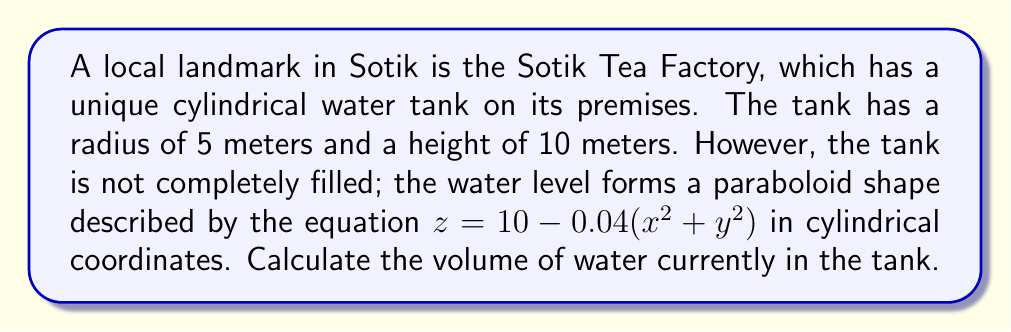Help me with this question. To solve this problem, we need to use a triple integral in cylindrical coordinates. The steps are as follows:

1) First, we set up the triple integral. In cylindrical coordinates, the volume is given by:

   $$V = \int_0^{2\pi} \int_0^R \int_0^{h(r)} r \, dz \, dr \, d\theta$$

   where $R$ is the radius of the base, and $h(r)$ is the height of the water as a function of $r$.

2) We know $R = 5$ meters. To find $h(r)$, we need to convert the equation of the paraboloid from Cartesian to cylindrical coordinates:

   $z = 10 - 0.04(x^2 + y^2)$ becomes $z = 10 - 0.04r^2$

3) Now we can set up our integral:

   $$V = \int_0^{2\pi} \int_0^5 \int_0^{10-0.04r^2} r \, dz \, dr \, d\theta$$

4) Let's solve the inner integral first:

   $$\int_0^{10-0.04r^2} r \, dz = r(10-0.04r^2)$$

5) Now our double integral looks like this:

   $$V = \int_0^{2\pi} \int_0^5 r(10-0.04r^2) \, dr \, d\theta$$

6) Solve the $r$ integral:

   $$\int_0^5 r(10-0.04r^2) \, dr = \left[5r^2 - \frac{0.04r^4}{4}\right]_0^5 = 125 - 62.5 = 62.5$$

7) Finally, integrate with respect to $\theta$:

   $$V = \int_0^{2\pi} 62.5 \, d\theta = 62.5 \cdot 2\pi = 125\pi$$

Therefore, the volume of water in the tank is $125\pi$ cubic meters.
Answer: $125\pi$ cubic meters 